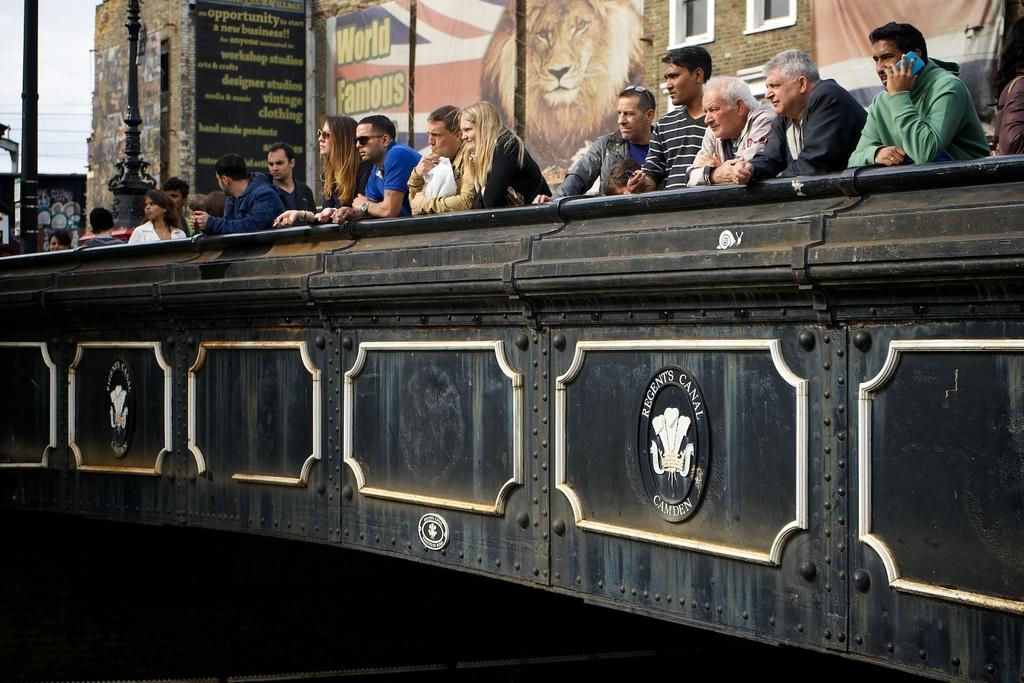<image>
Describe the image concisely. A group of people are looking out over a bridge and a sign behind them says World Famous. 